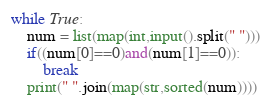Convert code to text. <code><loc_0><loc_0><loc_500><loc_500><_Python_>while True:
    num = list(map(int,input().split(" ")))
    if((num[0]==0)and(num[1]==0)):
        break
    print(" ".join(map(str,sorted(num))))</code> 